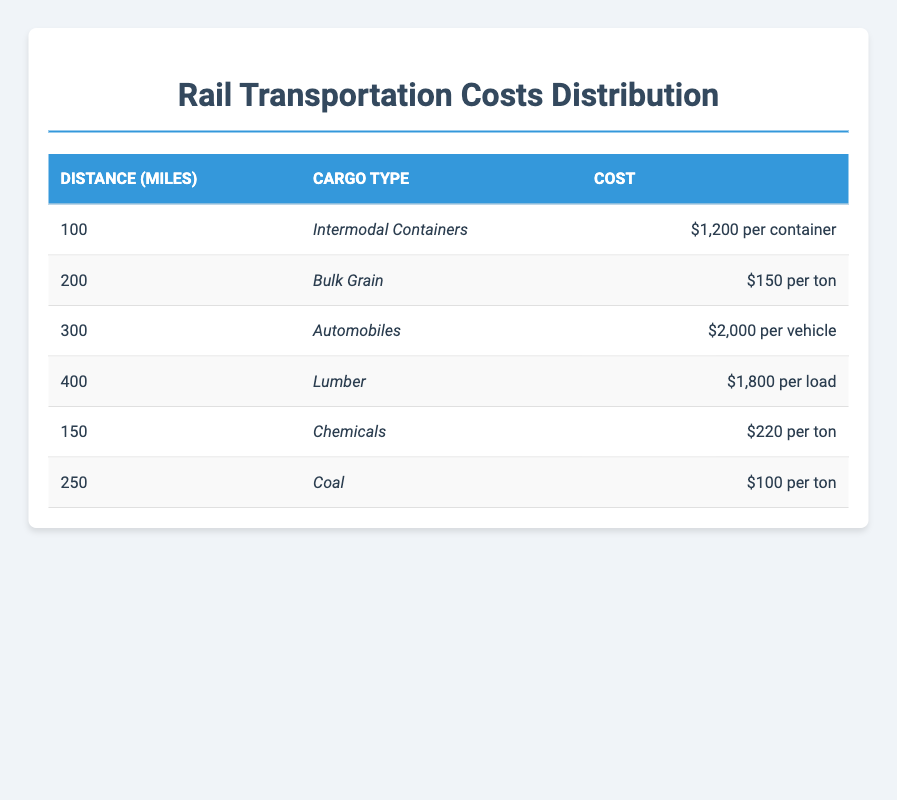What is the cost for transporting Intermodal Containers over 100 miles? The table lists the cost for transporting Intermodal Containers as $1,200 per container specifically for a distance of 100 miles.
Answer: $1,200 Which cargo type has the lowest cost per ton? In the table, Coal has a cost of $100 per ton, which is lower than the costs for Bulk Grain at $150 per ton and Chemicals at $220 per ton.
Answer: Coal What is the total cost if two loads of Lumber are transported over 400 miles? The cost for one load of Lumber over 400 miles is $1,800. Therefore, for two loads, the total cost would be 2 x $1,800 = $3,600.
Answer: $3,600 Is the cost for transporting Automobiles higher than the cost for transporting Lumber? The cost for Automobiles is $2,000 per vehicle and for Lumber is $1,800 per load. Since $2,000 is greater than $1,800, the statement is true.
Answer: Yes What is the average cost of transporting each type of cargo listed in the table? To find the average, we calculate the cost values: $1,200 (Intermodal Containers) + $150 (Bulk Grain) + $2,000 (Automobiles) + $1,800 (Lumber) + $220 (Chemicals) + $100 (Coal) = $5,470. Then, divide by the 6 types of cargo, resulting in an average cost of $5,470 / 6 ≈ $911.67.
Answer: Approximately $911.67 How much more does it cost to transport Automobiles compared to Coal? The cost for transporting Automobiles is $2,000 per vehicle and for Coal, it is $100 per ton. The difference is $2,000 - $100 = $1,900.
Answer: $1,900 